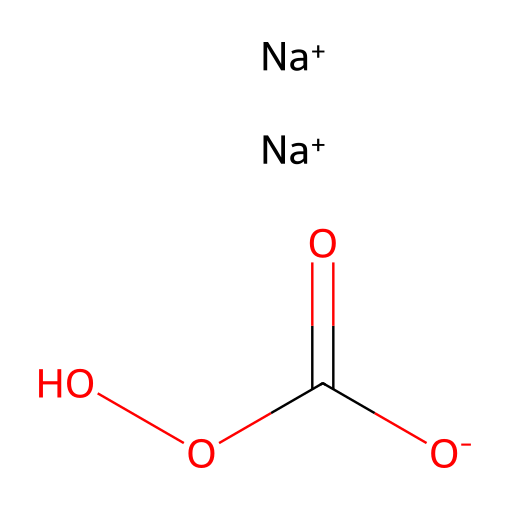What is the total number of sodium atoms in this chemical? The SMILES representation shows two instances of [Na+], indicating there are two sodium atoms in total.
Answer: two How many oxygen atoms are present in this compound? The structure presents four oxygen atoms: two from the [O-]C(=O) end and two from the OO part of the molecule.
Answer: four What is the molecular formula for sodium percarbonate? By analyzing the components of the structure, one can deduce that the molecular formula is Na2(C6H10O8), which corresponds to sodium percarbonate.
Answer: Na2(C6H10O8) What is the oxidation state of sodium in this compound? Sodium in ionic compounds has a consistent oxidation state of +1, as evident from the representation [Na+].
Answer: +1 Why is sodium percarbonate considered an oxidizer? The presence of the peroxide linkage (C(=O)OO) indicates the compound can release oxygen and thus acts as an oxidizing agent.
Answer: oxidizing agent How does sodium percarbonate contribute to fabric care? Sodium percarbonate acts as a bleach, releasing active oxygen when dissolved in water, helping to remove stains and whiten fabrics.
Answer: bleach 